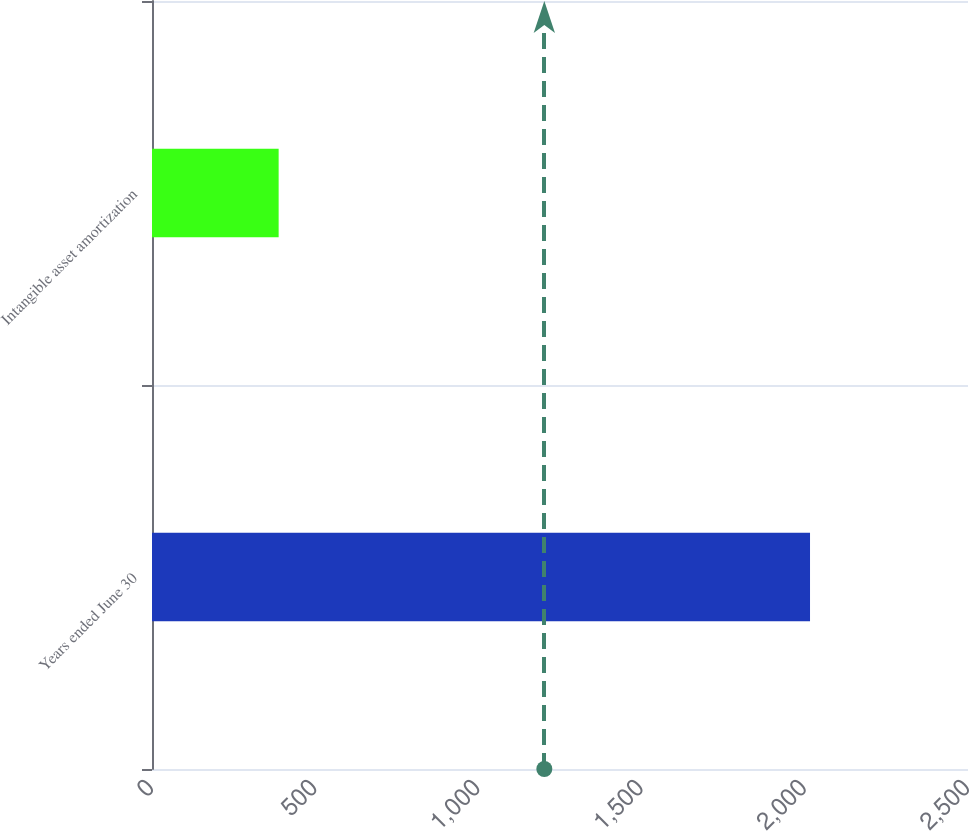<chart> <loc_0><loc_0><loc_500><loc_500><bar_chart><fcel>Years ended June 30<fcel>Intangible asset amortization<nl><fcel>2016<fcel>388<nl></chart> 